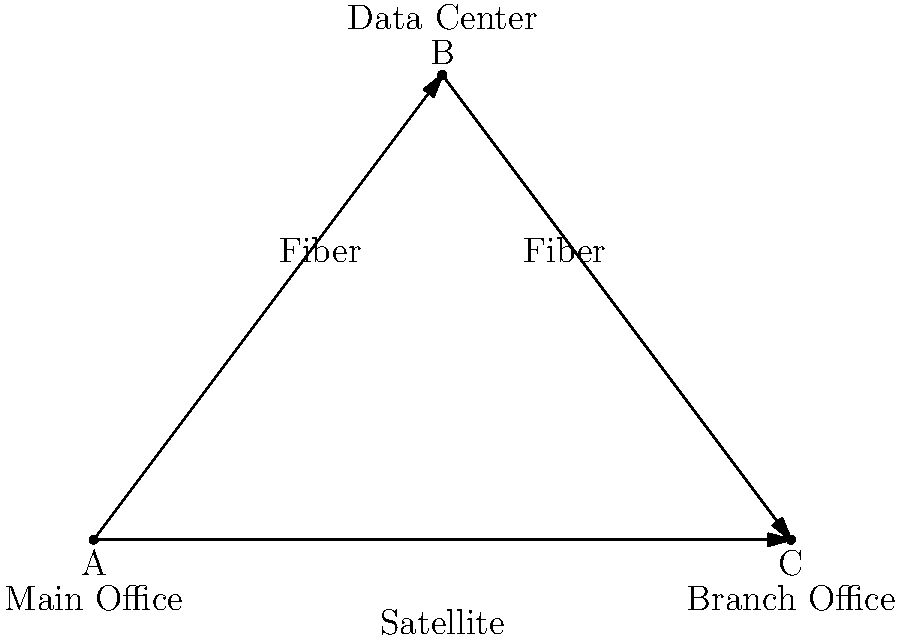As a content creator who understands the importance of clear communication, you've been asked to explain a network design to a client. The diagram shows a redundant network structure connecting a Main Office, Data Center, and Branch Office. Given that the primary connections are fiber optic and the backup is satellite, what is the most effective way to ensure continuous connectivity between all three locations? To ensure continuous connectivity between all three locations, we need to consider the following steps:

1. Analyze the primary connections:
   - Fiber optic links connect Main Office to Data Center and Data Center to Branch Office.
   - Fiber offers high speed and low latency, making it ideal for primary connections.

2. Identify the backup connection:
   - A satellite link connects Main Office directly to Branch Office.
   - Satellite provides wider coverage but with higher latency compared to fiber.

3. Understand the redundancy concept:
   - If any single connection fails, the network should remain operational.
   - The triangle topology provides multiple paths for data flow.

4. Consider traffic routing:
   - Under normal conditions, traffic should use the fiber links for optimal performance.
   - If a fiber link fails, traffic can be rerouted through the remaining connections.

5. Implement failover mechanisms:
   - Use routing protocols (e.g., OSPF or BGP) to automatically detect link failures.
   - Configure these protocols to reroute traffic through available paths.

6. Ensure consistent connectivity:
   - The Data Center acts as a central hub, connecting to both offices via fiber.
   - The satellite link serves as a direct backup between the offices.

7. Optimize for business continuity:
   - This design allows for uninterrupted operations even if one link fails.
   - The satellite backup ensures connectivity in case of widespread fiber outages.

The most effective way to ensure continuous connectivity is to implement dynamic routing protocols that can quickly detect link failures and reroute traffic through the available paths, utilizing the fiber connections primarily and falling back to the satellite link when necessary.
Answer: Implement dynamic routing protocols for automatic failover between fiber and satellite links. 